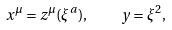Convert formula to latex. <formula><loc_0><loc_0><loc_500><loc_500>x ^ { \mu } = z ^ { \mu } ( \xi ^ { a } ) , \quad y = \xi ^ { 2 } ,</formula> 